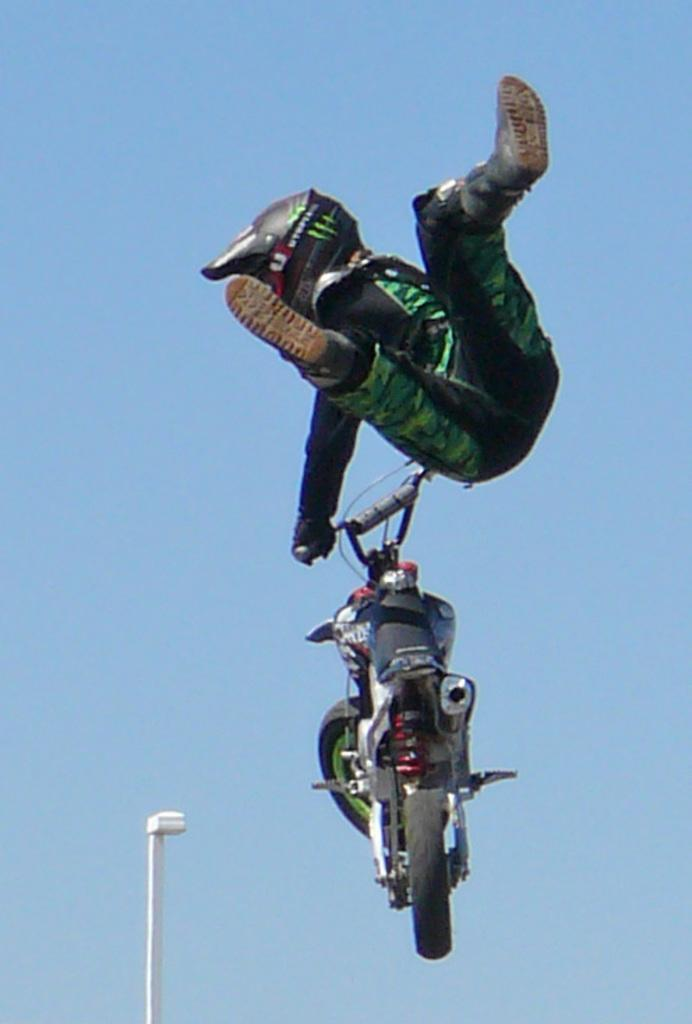What is the main subject of the image? The main subject of the image is a motorcycle. Is there anyone with the motorcycle in the image? Yes, a person is present in the image. What is the person wearing for safety? The person is wearing a helmet. What can be seen in the background of the image? There is a white pole and the sky visible in the image. What type of string is being used to hold the motorcycle in the image? There is no string present in the image; the motorcycle is not being held up by any visible means. 